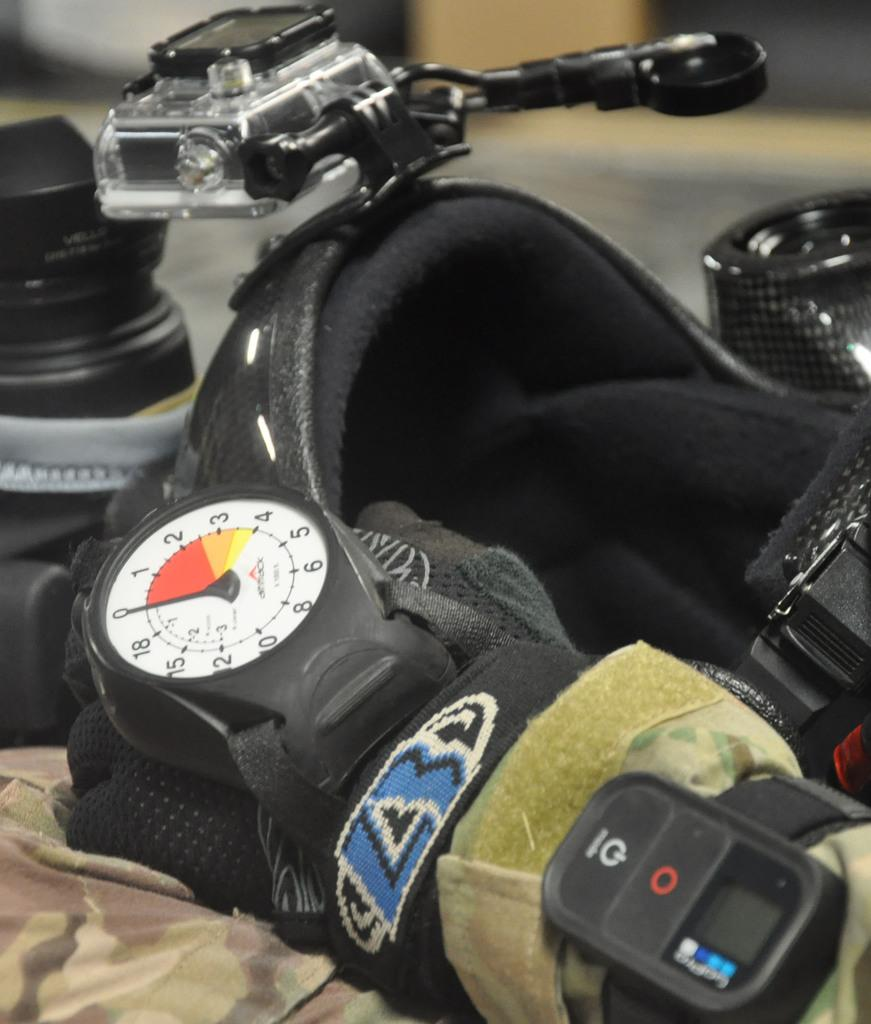What is the main subject of the image? The main subject of the image is a motorbike. Can you describe any other objects present in the image? Yes, there are some objects in the image. What type of rhythm does the motorbike have in the image? The motorbike does not have a rhythm in the image, as it is a stationary object. Can you tell me where the bulb is located in the image? There is no bulb present in the image. 